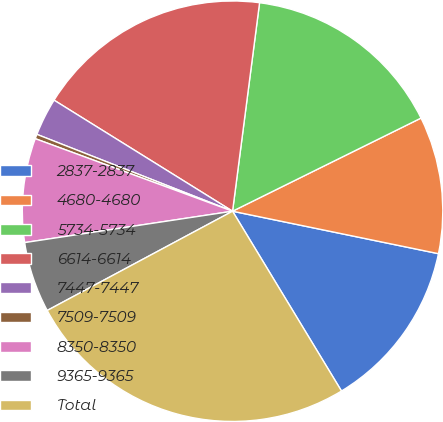<chart> <loc_0><loc_0><loc_500><loc_500><pie_chart><fcel>2837-2837<fcel>4680-4680<fcel>5734-5734<fcel>6614-6614<fcel>7447-7447<fcel>7509-7509<fcel>8350-8350<fcel>9365-9365<fcel>Total<nl><fcel>13.09%<fcel>10.54%<fcel>15.64%<fcel>18.19%<fcel>2.9%<fcel>0.35%<fcel>7.99%<fcel>5.44%<fcel>25.84%<nl></chart> 